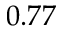<formula> <loc_0><loc_0><loc_500><loc_500>0 . 7 7</formula> 